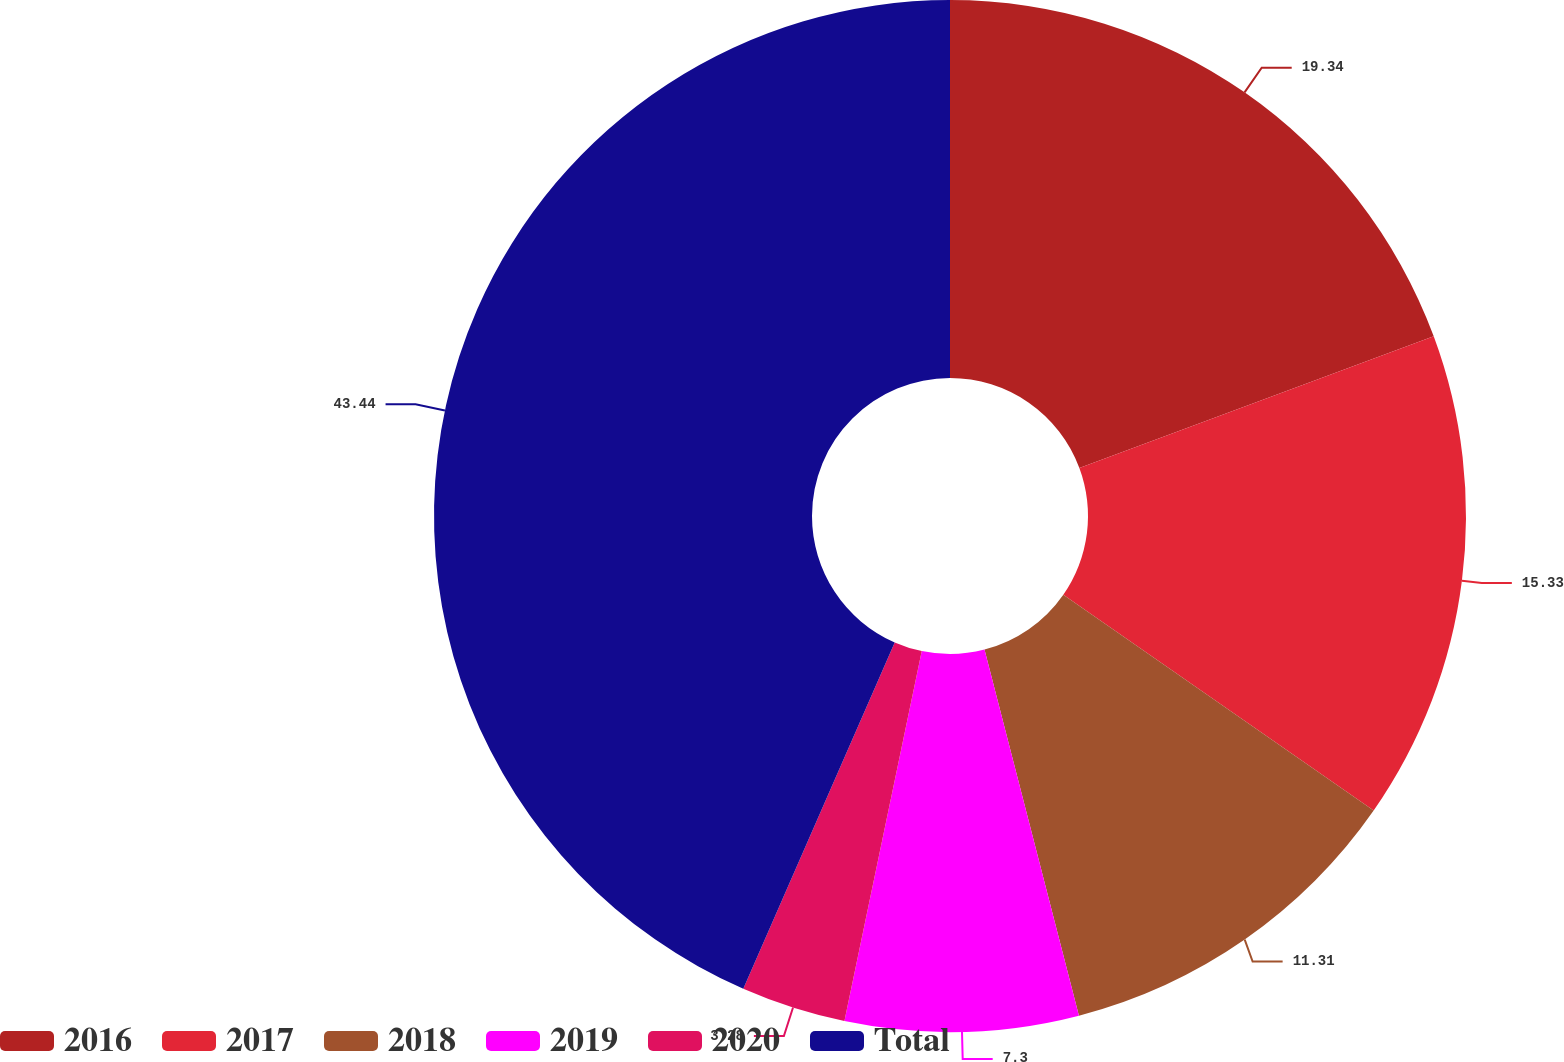<chart> <loc_0><loc_0><loc_500><loc_500><pie_chart><fcel>2016<fcel>2017<fcel>2018<fcel>2019<fcel>2020<fcel>Total<nl><fcel>19.34%<fcel>15.33%<fcel>11.31%<fcel>7.3%<fcel>3.28%<fcel>43.44%<nl></chart> 